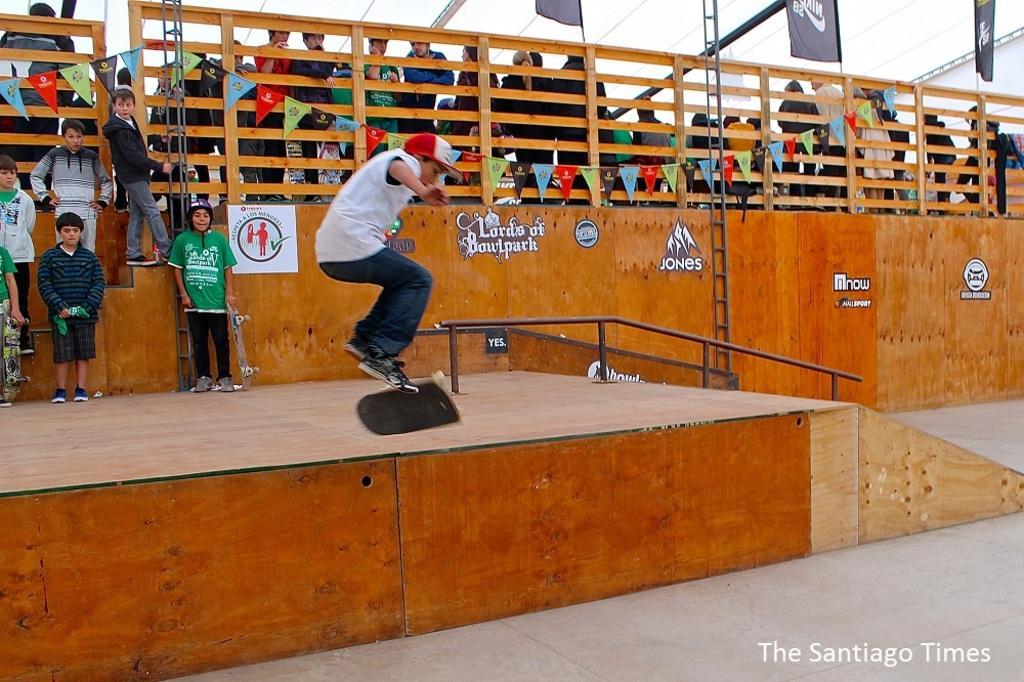How would you summarize this image in a sentence or two? This picture is clicked outside. In the center we can see a kid wearing white color t-shirt, cap and jumping in the air and we can see the skateboards, metal rods and we can see the group of people seems to be standing and we can see the wooden planks, text and some pictures on the posters. In the background we can see the sky, cables, flags and many other objects. In the bottom right corner we can see the text on the image. 